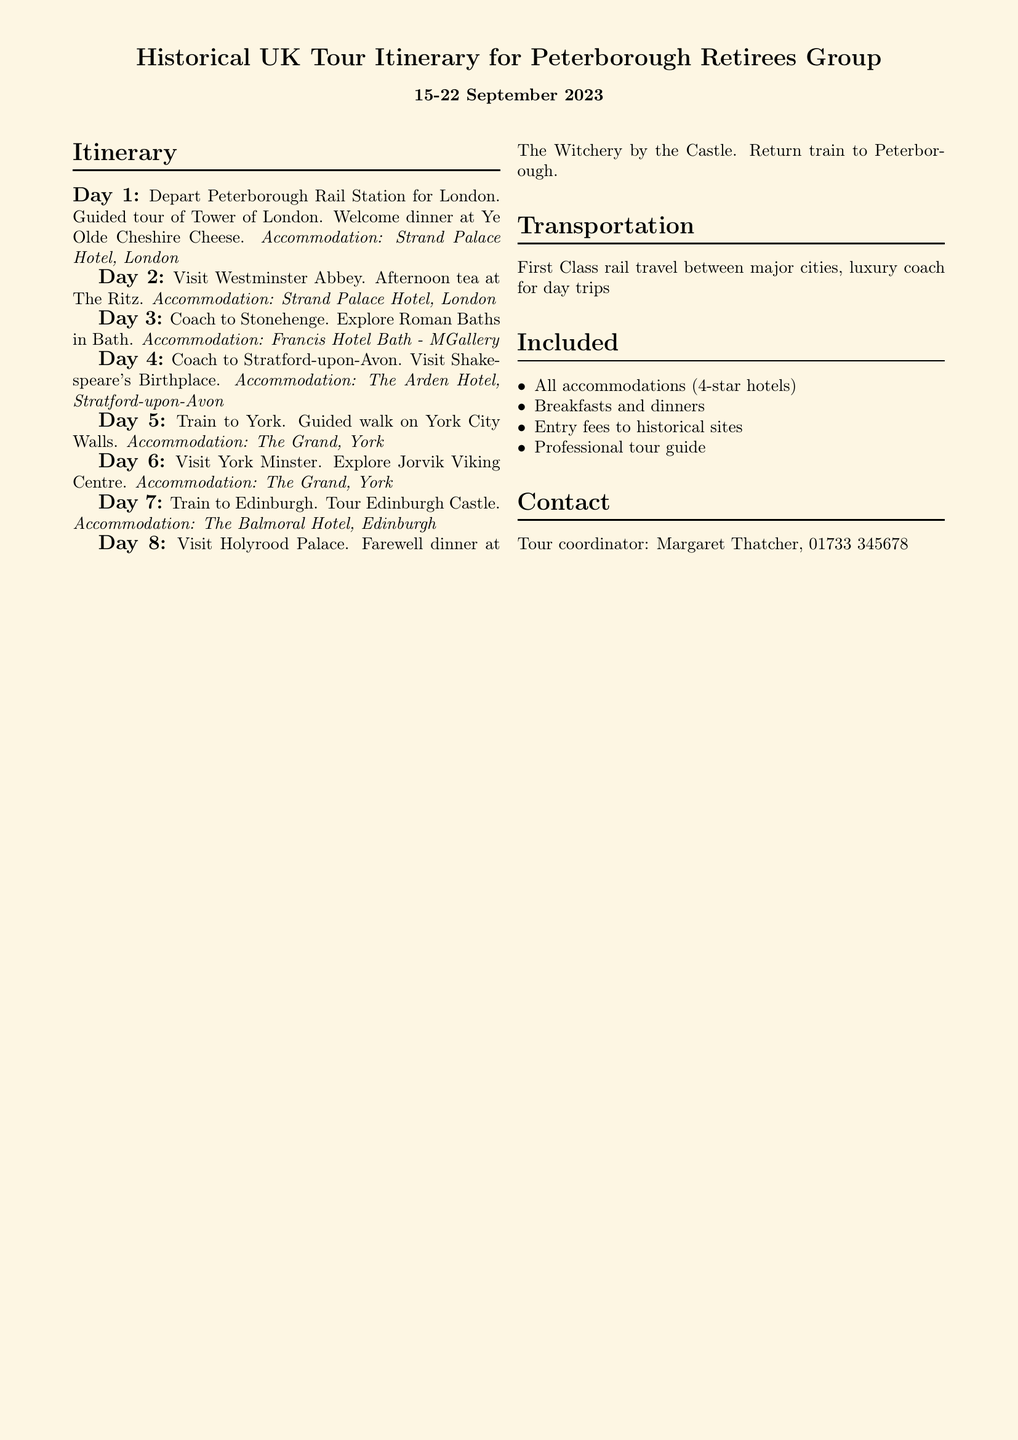what is the departure location for the tour? The departure location is mentioned as Peterborough Rail Station.
Answer: Peterborough Rail Station what is the accommodation in London? The accommodation provided during the London stay is specified.
Answer: Strand Palace Hotel, London how many days is the tour scheduled for? The itinerary outlines the tour duration.
Answer: 8 days which historical site is visited on Day 4? The document specifies the site visited on Day 4 of the itinerary.
Answer: Shakespeare's Birthplace what type of transportation is used for day trips? The document describes the mode of transportation for the excursions.
Answer: luxury coach who is the tour coordinator? The name of the tour coordinator is detailed in the contact section.
Answer: Margaret Thatcher which city does the group visit on Day 7? The itinerary states the city visited on Day 7.
Answer: Edinburgh how many 4-star hotels are included in the accommodations? The document lists the number of distinct accommodations with a quality rating.
Answer: 4 hotels 